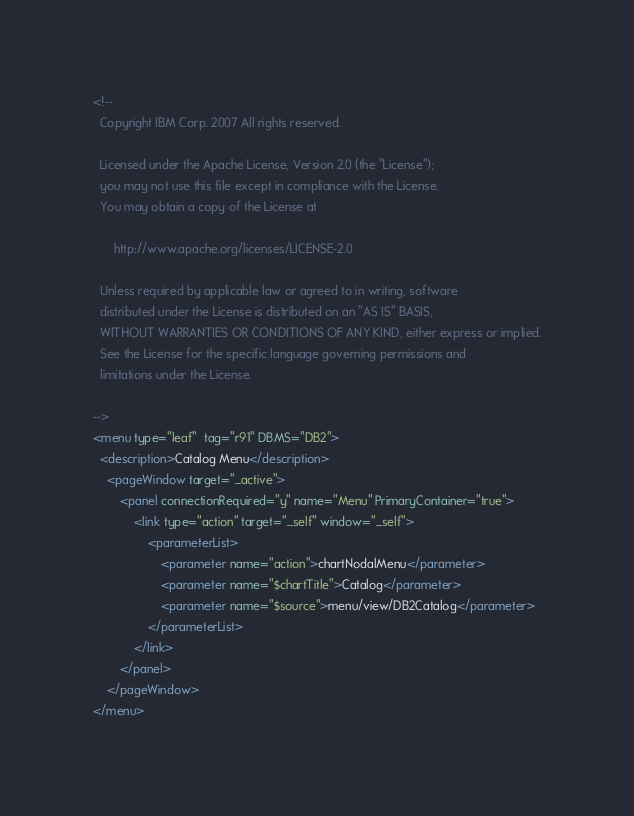Convert code to text. <code><loc_0><loc_0><loc_500><loc_500><_XML_><!--
  Copyright IBM Corp. 2007 All rights reserved.

  Licensed under the Apache License, Version 2.0 (the "License");
  you may not use this file except in compliance with the License.
  You may obtain a copy of the License at

      http://www.apache.org/licenses/LICENSE-2.0

  Unless required by applicable law or agreed to in writing, software
  distributed under the License is distributed on an "AS IS" BASIS,
  WITHOUT WARRANTIES OR CONDITIONS OF ANY KIND, either express or implied.
  See the License for the specific language governing permissions and
  limitations under the License.

-->
<menu type="leaf"  tag="r91" DBMS="DB2">
  <description>Catalog Menu</description>
	<pageWindow target="_active">
		<panel connectionRequired="y" name="Menu" PrimaryContainer="true">
			<link type="action" target="_self" window="_self">
				<parameterList>
					<parameter name="action">chartNodalMenu</parameter>
					<parameter name="$chartTitle">Catalog</parameter>
					<parameter name="$source">menu/view/DB2Catalog</parameter>
				</parameterList>
			</link>				
		</panel>
	</pageWindow>
</menu>
</code> 